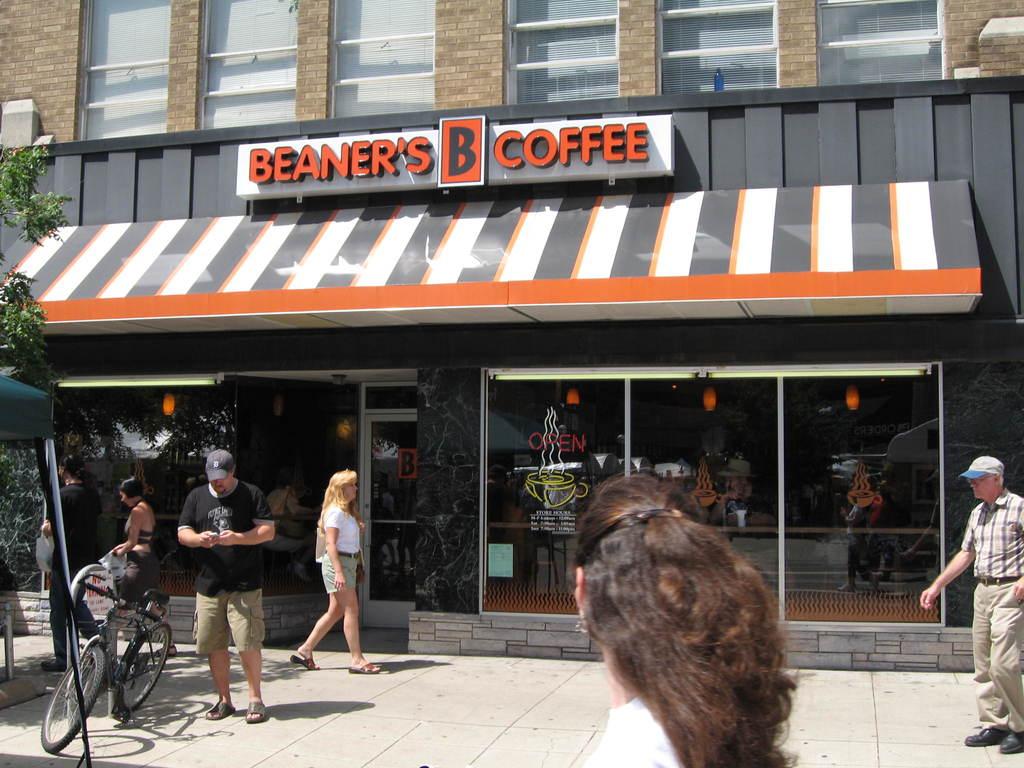What company storefront is shown here?
Provide a short and direct response. Beaner's coffee. What is written on the neon sign above the yellow coffee cup?
Your response must be concise. Open. 